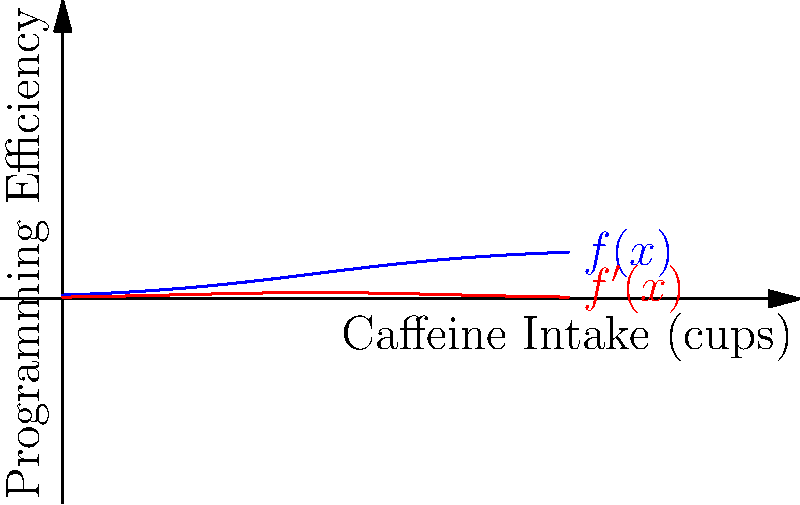Given the sigmoid function $f(x) = \frac{1}{1 + e^{-0.5(x-5)}}$ modeling the relationship between caffeine intake (x) and programming efficiency, find the caffeine intake level that maximizes the rate of change in programming efficiency. To find the caffeine intake level that maximizes the rate of change in programming efficiency, we need to follow these steps:

1) The rate of change is given by the derivative of $f(x)$. Let's calculate $f'(x)$:
   
   $f'(x) = \frac{0.5e^{-0.5(x-5)}}{(1 + e^{-0.5(x-5)})^2}$

2) To find the maximum of $f'(x)$, we need to find where its derivative equals zero. Let's calculate $f''(x)$:
   
   $f''(x) = \frac{0.5e^{-0.5(x-5)}(1 + e^{-0.5(x-5)})(-0.5) - 0.5e^{-0.5(x-5)}(2)(1 + e^{-0.5(x-5)})(-0.5e^{-0.5(x-5)})}{(1 + e^{-0.5(x-5)})^4}$

3) Simplify $f''(x) = 0$:
   
   $0.5e^{-0.5(x-5)}(1 + e^{-0.5(x-5)})(-0.5) = 0.5e^{-0.5(x-5)}(2)(1 + e^{-0.5(x-5)})(-0.5e^{-0.5(x-5)})$
   
   $1 + e^{-0.5(x-5)} = 2e^{-0.5(x-5)}$
   
   $1 = e^{-0.5(x-5)}$
   
   $0 = -0.5(x-5)$
   
   $x = 5$

4) Verify this is a maximum by checking the sign of $f''(x)$ around $x = 5$.

Therefore, the caffeine intake level that maximizes the rate of change in programming efficiency is 5 cups.
Answer: 5 cups 